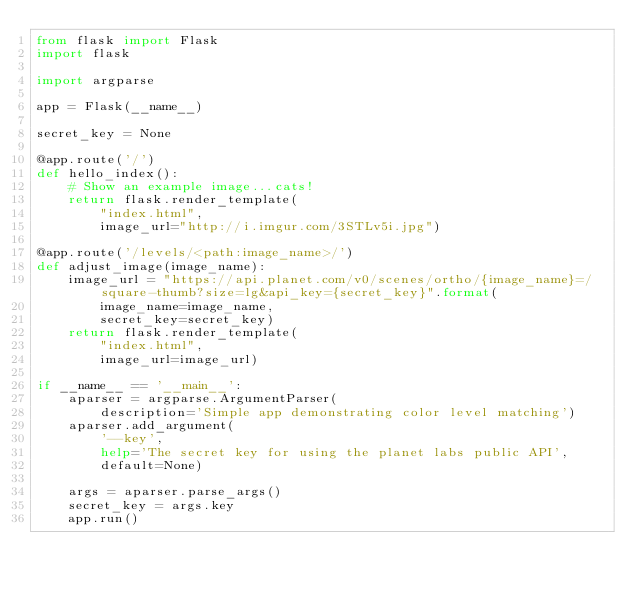Convert code to text. <code><loc_0><loc_0><loc_500><loc_500><_Python_>from flask import Flask
import flask

import argparse

app = Flask(__name__)

secret_key = None

@app.route('/')
def hello_index():
    # Show an example image...cats!
    return flask.render_template(
        "index.html",
        image_url="http://i.imgur.com/3STLv5i.jpg")

@app.route('/levels/<path:image_name>/')
def adjust_image(image_name):
    image_url = "https://api.planet.com/v0/scenes/ortho/{image_name}=/square-thumb?size=lg&api_key={secret_key}".format(
        image_name=image_name,
        secret_key=secret_key)
    return flask.render_template(
        "index.html",
        image_url=image_url)

if __name__ == '__main__':
    aparser = argparse.ArgumentParser(
        description='Simple app demonstrating color level matching')
    aparser.add_argument(
        '--key',
        help='The secret key for using the planet labs public API',
        default=None)

    args = aparser.parse_args()
    secret_key = args.key
    app.run()


</code> 